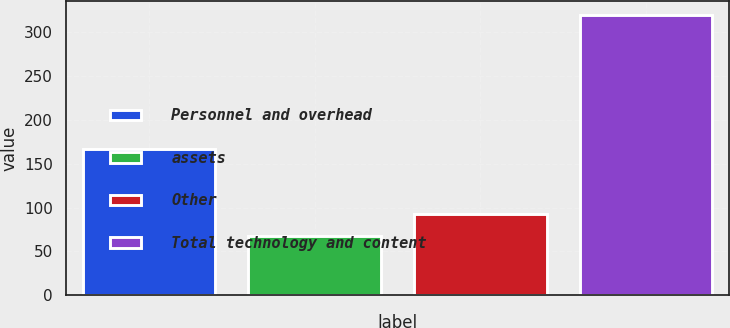Convert chart. <chart><loc_0><loc_0><loc_500><loc_500><bar_chart><fcel>Personnel and overhead<fcel>assets<fcel>Other<fcel>Total technology and content<nl><fcel>167<fcel>68<fcel>93.2<fcel>320<nl></chart> 